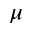Convert formula to latex. <formula><loc_0><loc_0><loc_500><loc_500>\mu</formula> 